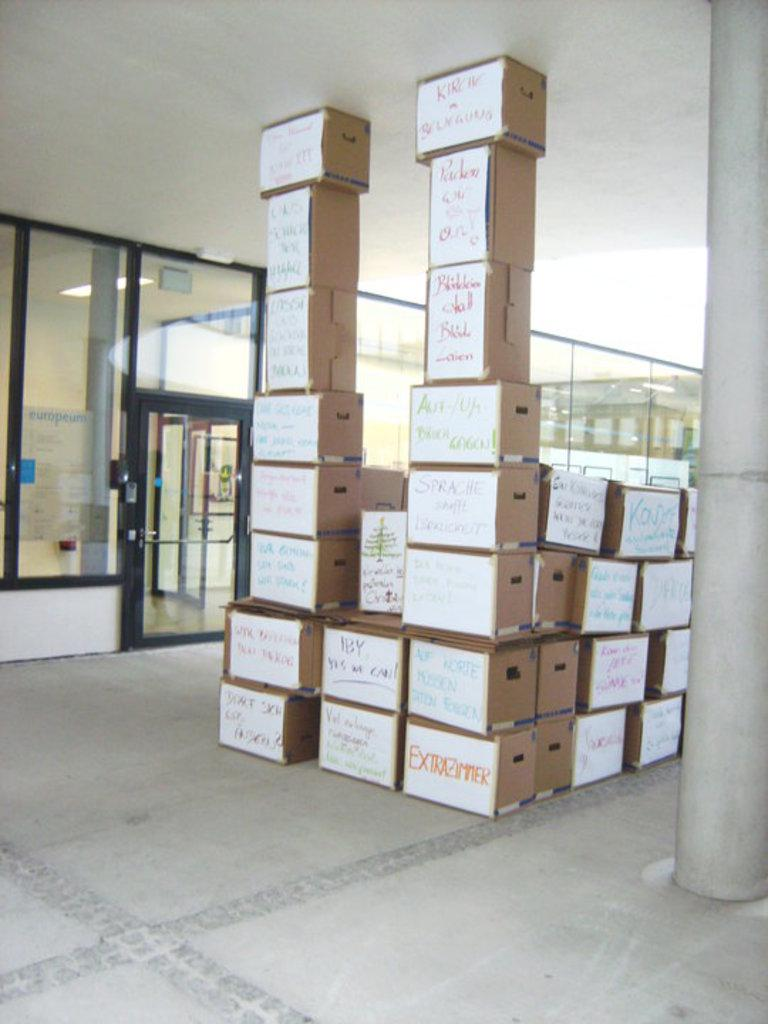<image>
Offer a succinct explanation of the picture presented. a group of boxes with on that says extrazimmer on it 